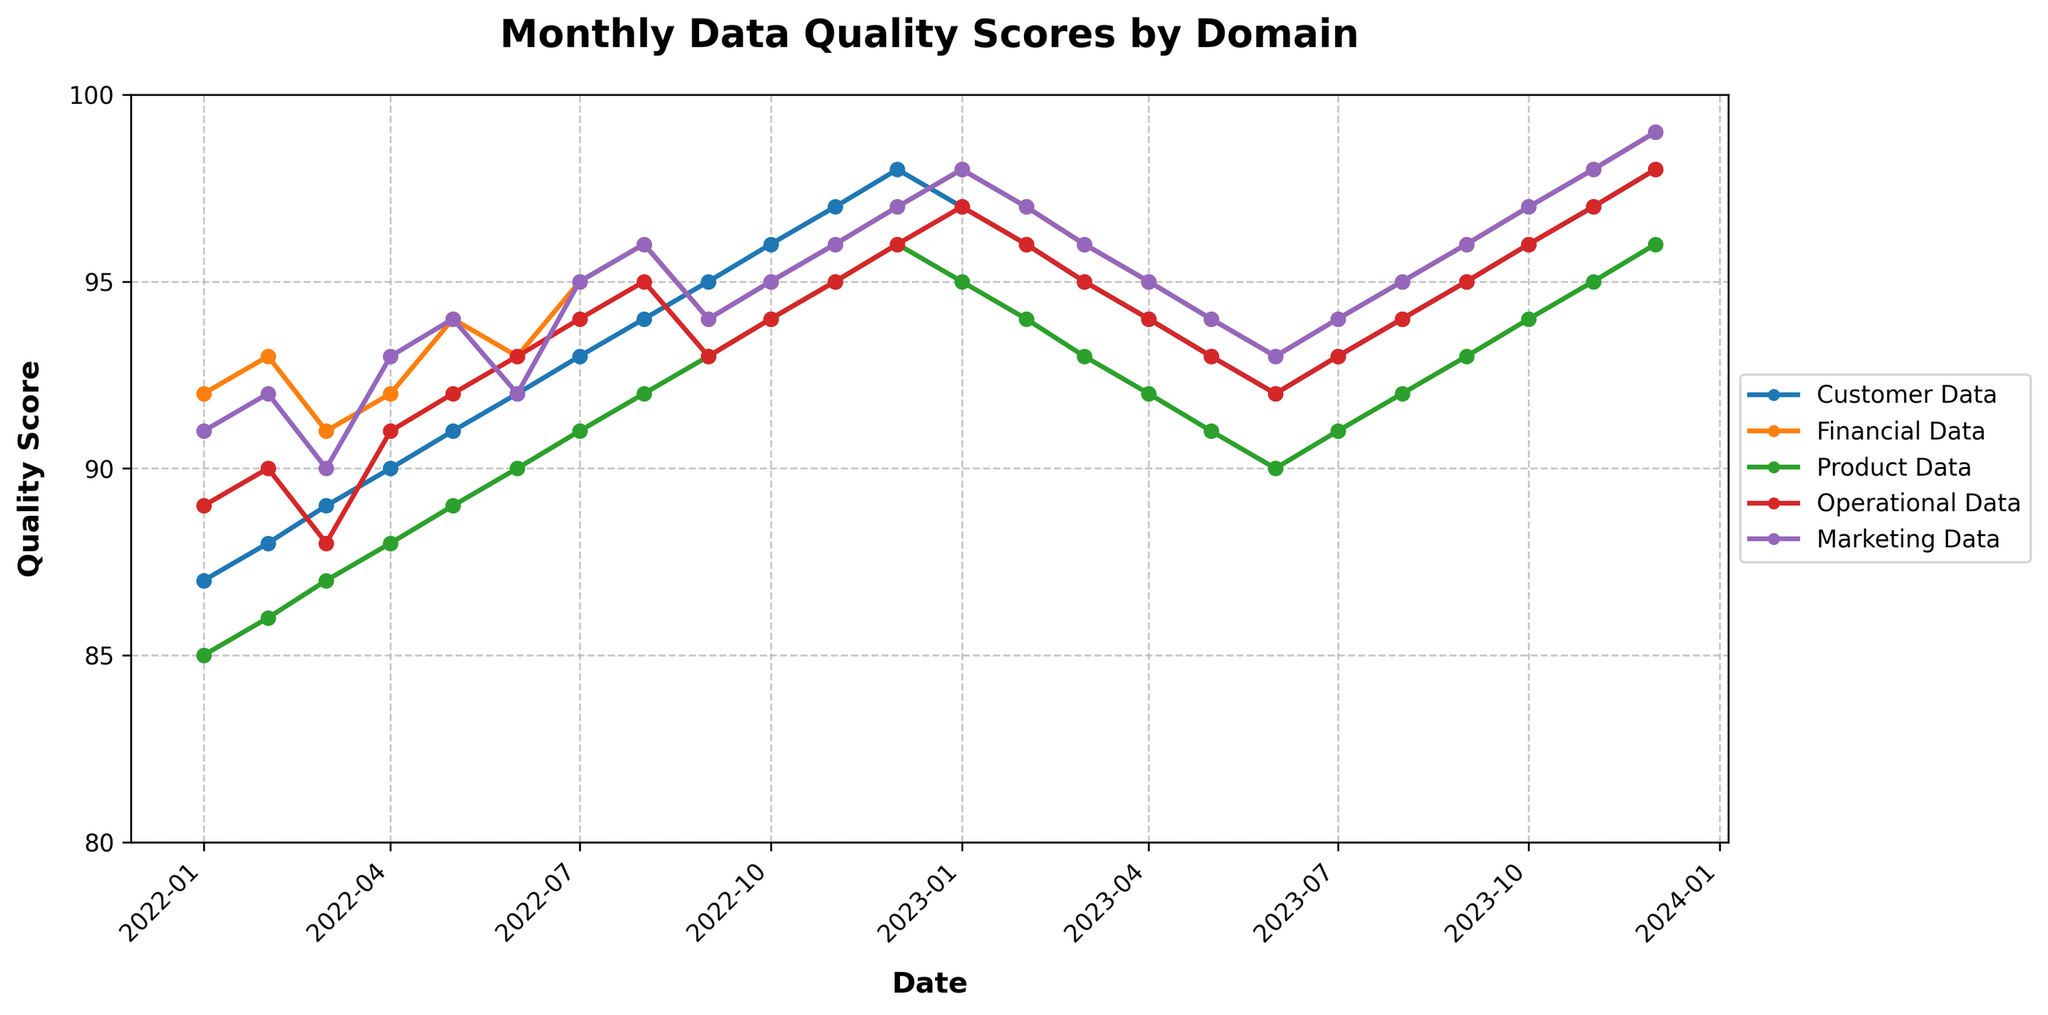What is the highest data quality score for Customer Data over the plotted time frame? To determine the highest data quality score for Customer Data, observe the maximum point of the Customer Data line on the plot. The plot shows Customer Data reaching up to 98, which is the highest value.
Answer: 98 Which data domain scored the highest in November 2023? Look at the data points plotted for November 2023 across all domains. Each data domain has a score for November 2023, and the Marketing Data domain reaches the highest value with a score of 98.
Answer: Marketing Data What trend can you observe for Financial Data from January 2022 to December 2023? Examine the line representing Financial Data. Initially, there is a general upward trend from January 2022 to December 2022, followed by a slight fluctuation but overall stability from January 2023 to December 2023.
Answer: Initially upward, then stable Which data domain shows the greatest variability over the two-year period? Assess the lines on the plot to see which fluctuates the most. The Product Data line shows the most ups and downs, indicating the greatest variability.
Answer: Product Data What's the average data quality score for Product Data in 2022? Note down the monthly scores for Product Data in 2022: (85, 86, 87, 88, 89, 90, 91, 92, 93, 94, 95, 96). Calculate the average: (85+86+87+88+89+90+91+92+93+94+95+96) / 12 = 91.
Answer: 91 By how many points did Customer Data quality improve from January 2022 to December 2022? Observe the Customer Data scores for January and December 2022. The scores are 87 in January and 98 in December. The increase is 98 - 87 = 11 points.
Answer: 11 Is there any month where all domains have a quality score of 95 or higher? Review each month and check if the scores for all domains are 95 or above. In December 2023, all domains have scores of 95 or above.
Answer: December 2023 Between which two consecutive months did the Operational Data quality decrease the most significantly? Analyze the Operational Data line for the steepest decline between two consecutive points. The largest drop occurs between January and February 2023, with a decrease from 97 to 96.
Answer: January to February 2023 What is the average quality score for all data domains in January 2023? Sum the scores for all domains in January 2023: (97, 98, 95, 97, 98). Calculate the average: (97+98+95+97+98) / 5 = 97.
Answer: 97 Which data domain consistently scored above 90 throughout the entire time frame? Observe each domain's line on the plot and check for any dips below 90. Financial Data consistently scores above 90 for the entire period.
Answer: Financial Data 